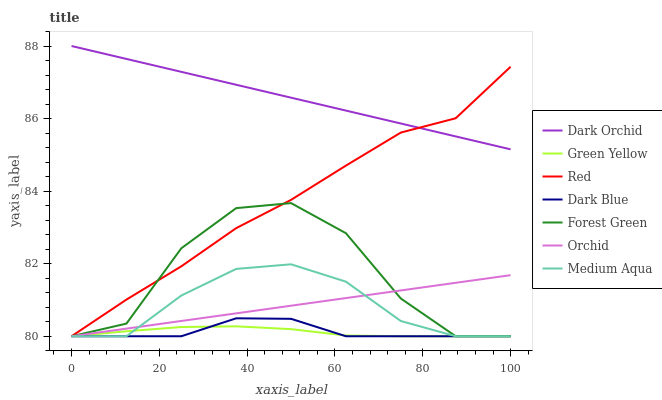Does Green Yellow have the minimum area under the curve?
Answer yes or no. Yes. Does Dark Orchid have the maximum area under the curve?
Answer yes or no. Yes. Does Dark Blue have the minimum area under the curve?
Answer yes or no. No. Does Dark Blue have the maximum area under the curve?
Answer yes or no. No. Is Orchid the smoothest?
Answer yes or no. Yes. Is Forest Green the roughest?
Answer yes or no. Yes. Is Dark Blue the smoothest?
Answer yes or no. No. Is Dark Blue the roughest?
Answer yes or no. No. Does Dark Blue have the lowest value?
Answer yes or no. Yes. Does Dark Orchid have the highest value?
Answer yes or no. Yes. Does Dark Blue have the highest value?
Answer yes or no. No. Is Forest Green less than Dark Orchid?
Answer yes or no. Yes. Is Dark Orchid greater than Medium Aqua?
Answer yes or no. Yes. Does Red intersect Forest Green?
Answer yes or no. Yes. Is Red less than Forest Green?
Answer yes or no. No. Is Red greater than Forest Green?
Answer yes or no. No. Does Forest Green intersect Dark Orchid?
Answer yes or no. No. 